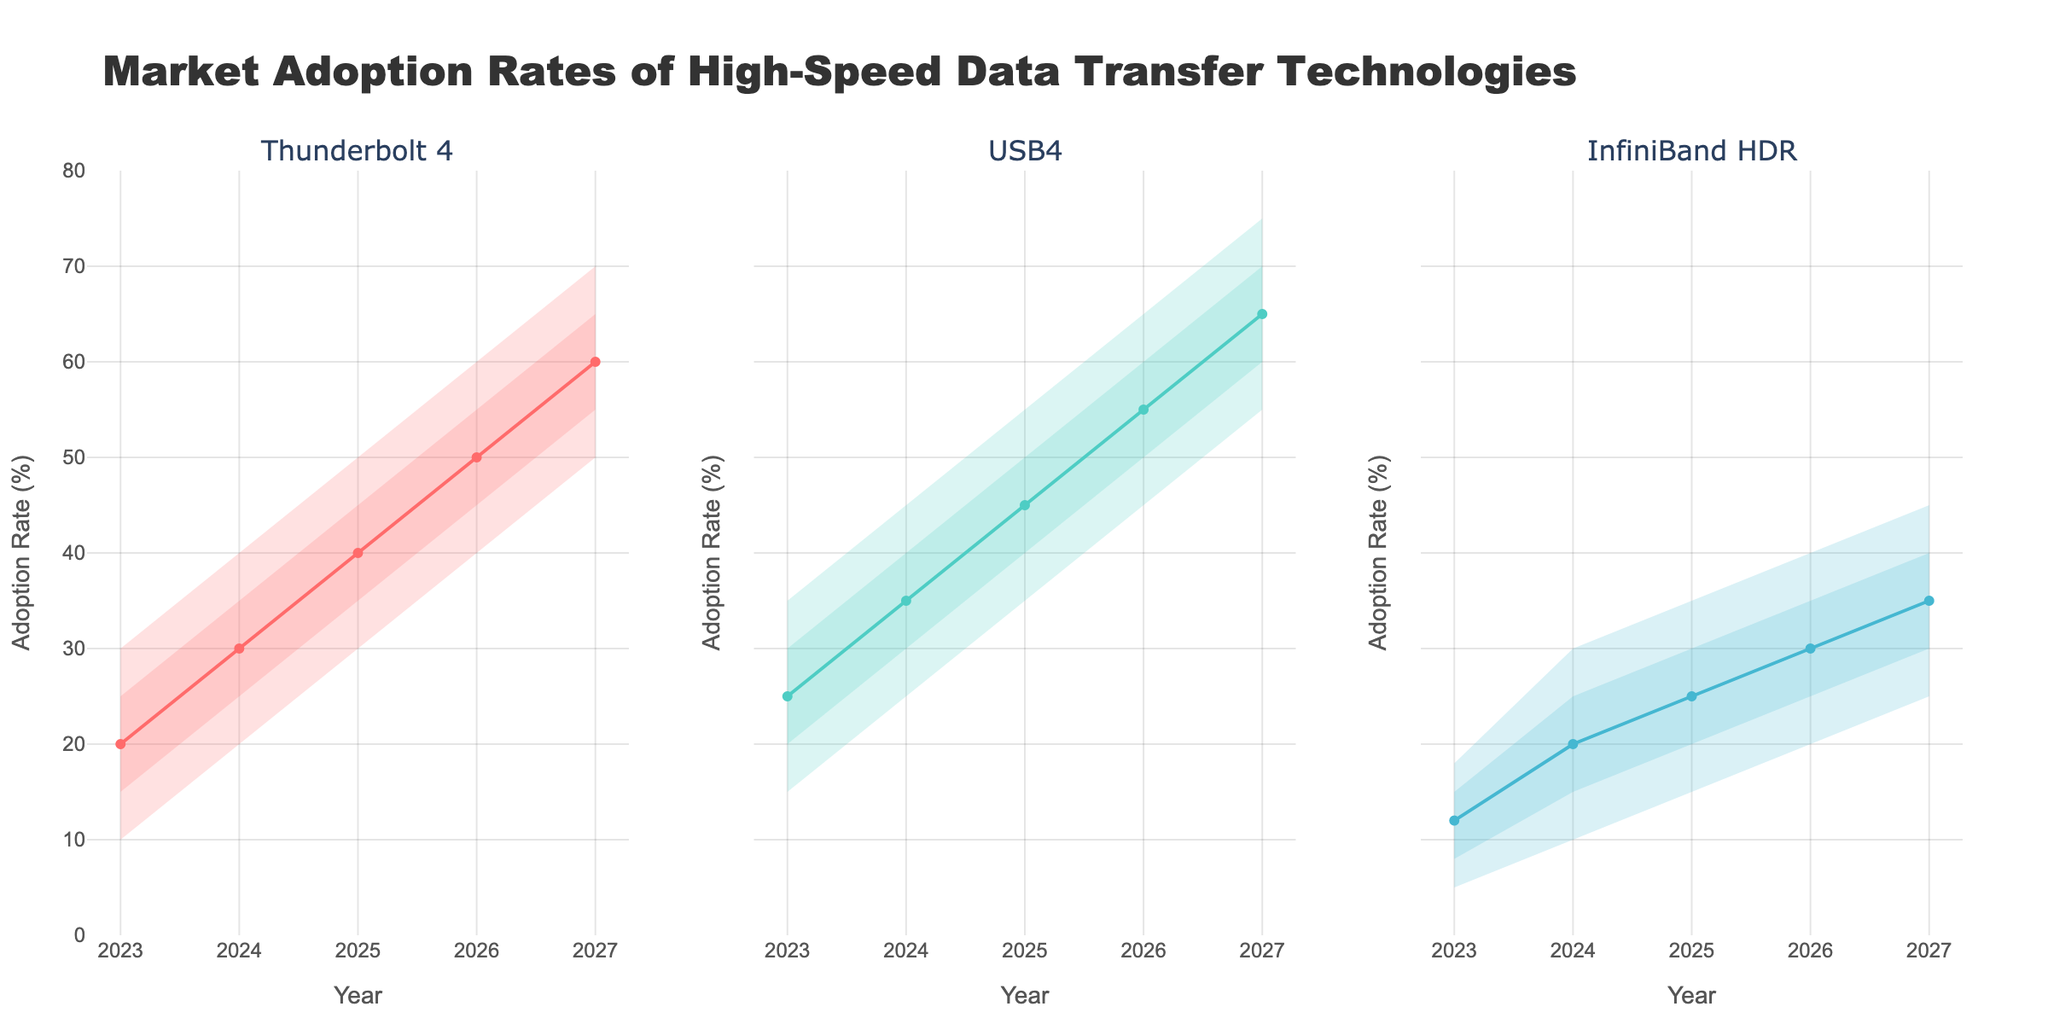What are the technologies displayed in the figure? The plot contains subplots with the titles of the data transfer technologies. By looking at these titles, we identify the technologies.
Answer: Thunderbolt 4, USB4, InfiniBand HDR What is the highest adoption rate for Thunderbolt 4 in 2023? By examining the Thunderbolt 4 subplot for the year 2023, we see the band's range, with the highest point reaching up to 30%.
Answer: 30% What is the median adoption rate of USB4 in 2026? Check the middle line (Med) for the USB4 subplot in 2026, and locate its value.
Answer: 55% How does the adoption rate of InfiniBand HDR change from 2023 to 2027? Look at the InfiniBand HDR subplot and compare the adoption rates from 2023 to 2027 in terms of the bands' positions.
Answer: It increases from 5%-18% in 2023 to 25%-45% in 2027 Which technology shows the fastest growth in median adoption rate from 2023 to 2027? Compare the medians (middle lines) for each technology in 2023 and 2027. Calculate the difference and determine the highest value.
Answer: USB4 Which year shows the least uncertainty for USB4 adoption rates? Find the year where the range between Low and High values for USB4 is the smallest.
Answer: 2023 Among the three technologies, which one shows the most consistent growth in adoption rates? Look at the overall trend for the Mid values in each subplot. The growth consistency can be determined by the smooth steadiness of the median line.
Answer: Thunderbolt 4 In 2024, how does the highest predicted adoption rate of USB4 compare to Thunderbolt 4? Check the highest value for USB4 and Thunderbolt 4 in 2024 from their respective subplots and compare them.
Answer: Both have 45% Which technology has the broadest uncertainty range in 2027? Check the range between Low and High for each technology in 2027 and identify the broadest.
Answer: USB4 